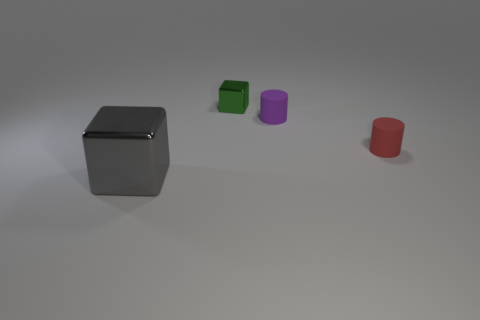There is a large metallic block; does it have the same color as the metal cube behind the big gray metal thing? no 